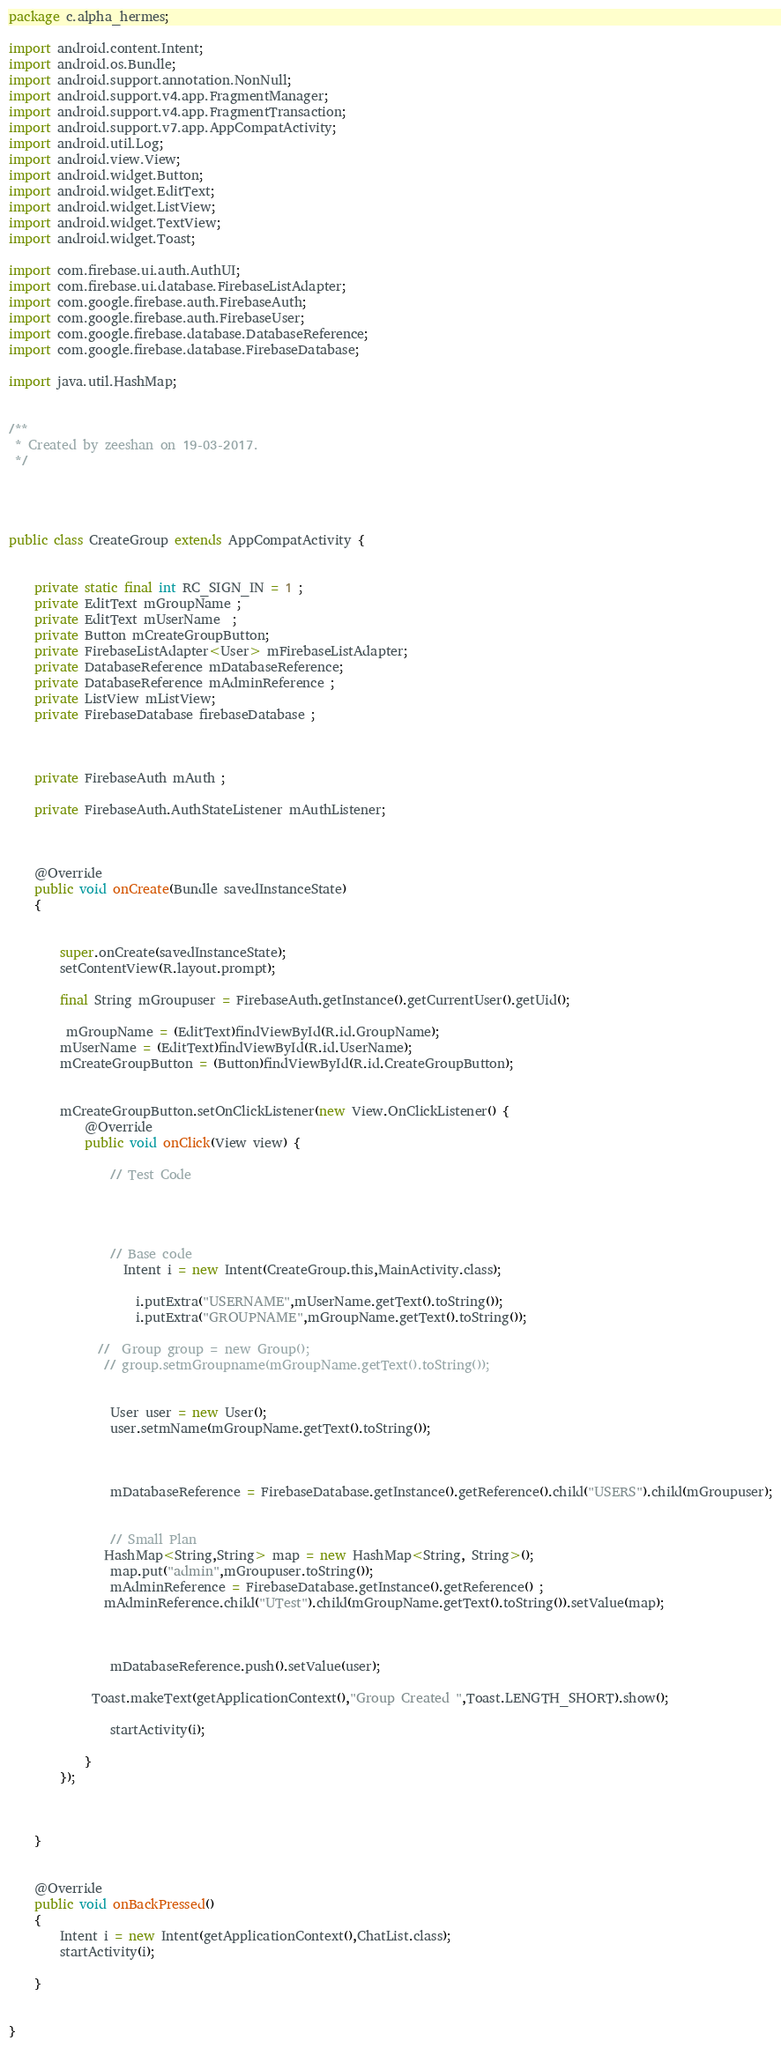Convert code to text. <code><loc_0><loc_0><loc_500><loc_500><_Java_>package c.alpha_hermes;

import android.content.Intent;
import android.os.Bundle;
import android.support.annotation.NonNull;
import android.support.v4.app.FragmentManager;
import android.support.v4.app.FragmentTransaction;
import android.support.v7.app.AppCompatActivity;
import android.util.Log;
import android.view.View;
import android.widget.Button;
import android.widget.EditText;
import android.widget.ListView;
import android.widget.TextView;
import android.widget.Toast;

import com.firebase.ui.auth.AuthUI;
import com.firebase.ui.database.FirebaseListAdapter;
import com.google.firebase.auth.FirebaseAuth;
import com.google.firebase.auth.FirebaseUser;
import com.google.firebase.database.DatabaseReference;
import com.google.firebase.database.FirebaseDatabase;

import java.util.HashMap;


/**
 * Created by zeeshan on 19-03-2017.
 */




public class CreateGroup extends AppCompatActivity {


    private static final int RC_SIGN_IN = 1 ;
    private EditText mGroupName ;
    private EditText mUserName  ;
    private Button mCreateGroupButton;
    private FirebaseListAdapter<User> mFirebaseListAdapter;
    private DatabaseReference mDatabaseReference;
    private DatabaseReference mAdminReference ;
    private ListView mListView;
    private FirebaseDatabase firebaseDatabase ;



    private FirebaseAuth mAuth ;

    private FirebaseAuth.AuthStateListener mAuthListener;



    @Override
    public void onCreate(Bundle savedInstanceState)
    {


        super.onCreate(savedInstanceState);
        setContentView(R.layout.prompt);

        final String mGroupuser = FirebaseAuth.getInstance().getCurrentUser().getUid();

         mGroupName = (EditText)findViewById(R.id.GroupName);
        mUserName = (EditText)findViewById(R.id.UserName);
        mCreateGroupButton = (Button)findViewById(R.id.CreateGroupButton);


        mCreateGroupButton.setOnClickListener(new View.OnClickListener() {
            @Override
            public void onClick(View view) {

                // Test Code




                // Base code
                  Intent i = new Intent(CreateGroup.this,MainActivity.class);

                    i.putExtra("USERNAME",mUserName.getText().toString());
                    i.putExtra("GROUPNAME",mGroupName.getText().toString());

              //  Group group = new Group();
               // group.setmGroupname(mGroupName.getText().toString());


                User user = new User();
                user.setmName(mGroupName.getText().toString());



                mDatabaseReference = FirebaseDatabase.getInstance().getReference().child("USERS").child(mGroupuser);


                // Small Plan
               HashMap<String,String> map = new HashMap<String, String>();
                map.put("admin",mGroupuser.toString());
                mAdminReference = FirebaseDatabase.getInstance().getReference() ;
               mAdminReference.child("UTest").child(mGroupName.getText().toString()).setValue(map);



                mDatabaseReference.push().setValue(user);

             Toast.makeText(getApplicationContext(),"Group Created ",Toast.LENGTH_SHORT).show();

                startActivity(i);

            }
        });



    }


    @Override
    public void onBackPressed()
    {
        Intent i = new Intent(getApplicationContext(),ChatList.class);
        startActivity(i);

    }


}
</code> 